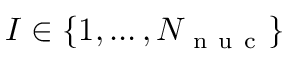Convert formula to latex. <formula><loc_0><loc_0><loc_500><loc_500>I \in \{ 1 , \dots , { N _ { n u c } } \}</formula> 